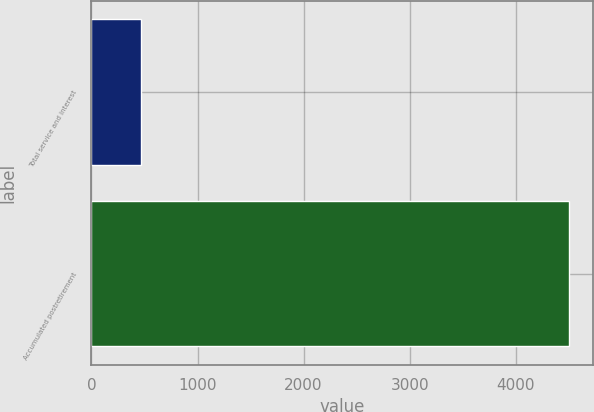Convert chart. <chart><loc_0><loc_0><loc_500><loc_500><bar_chart><fcel>Total service and interest<fcel>Accumulated postretirement<nl><fcel>465<fcel>4503<nl></chart> 